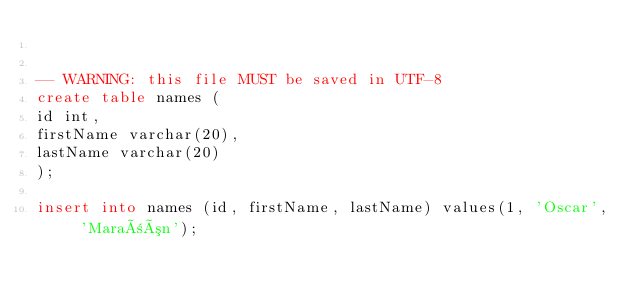Convert code to text. <code><loc_0><loc_0><loc_500><loc_500><_SQL_>

-- WARNING: this file MUST be saved in UTF-8
create table names (
id int,
firstName varchar(20),
lastName varchar(20)
);

insert into names (id, firstName, lastName) values(1, 'Oscar', 'Marañón');
</code> 